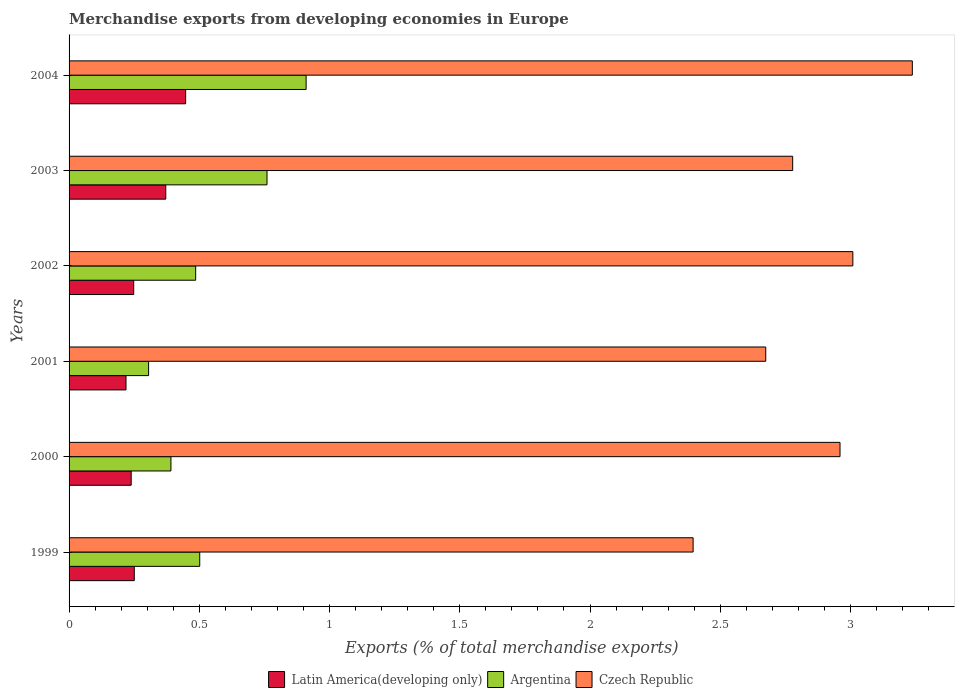Are the number of bars per tick equal to the number of legend labels?
Your answer should be compact. Yes. Are the number of bars on each tick of the Y-axis equal?
Provide a short and direct response. Yes. How many bars are there on the 2nd tick from the top?
Offer a terse response. 3. How many bars are there on the 3rd tick from the bottom?
Offer a very short reply. 3. What is the percentage of total merchandise exports in Latin America(developing only) in 2004?
Your response must be concise. 0.45. Across all years, what is the maximum percentage of total merchandise exports in Czech Republic?
Your response must be concise. 3.24. Across all years, what is the minimum percentage of total merchandise exports in Czech Republic?
Give a very brief answer. 2.4. In which year was the percentage of total merchandise exports in Argentina maximum?
Provide a short and direct response. 2004. What is the total percentage of total merchandise exports in Argentina in the graph?
Make the answer very short. 3.35. What is the difference between the percentage of total merchandise exports in Czech Republic in 1999 and that in 2002?
Your response must be concise. -0.61. What is the difference between the percentage of total merchandise exports in Latin America(developing only) in 2004 and the percentage of total merchandise exports in Czech Republic in 2003?
Provide a succinct answer. -2.33. What is the average percentage of total merchandise exports in Czech Republic per year?
Give a very brief answer. 2.84. In the year 2002, what is the difference between the percentage of total merchandise exports in Czech Republic and percentage of total merchandise exports in Latin America(developing only)?
Keep it short and to the point. 2.76. In how many years, is the percentage of total merchandise exports in Czech Republic greater than 1.6 %?
Your answer should be very brief. 6. What is the ratio of the percentage of total merchandise exports in Czech Republic in 1999 to that in 2002?
Ensure brevity in your answer.  0.8. Is the percentage of total merchandise exports in Latin America(developing only) in 2001 less than that in 2003?
Your answer should be very brief. Yes. Is the difference between the percentage of total merchandise exports in Czech Republic in 2003 and 2004 greater than the difference between the percentage of total merchandise exports in Latin America(developing only) in 2003 and 2004?
Give a very brief answer. No. What is the difference between the highest and the second highest percentage of total merchandise exports in Czech Republic?
Provide a succinct answer. 0.23. What is the difference between the highest and the lowest percentage of total merchandise exports in Argentina?
Provide a short and direct response. 0.6. In how many years, is the percentage of total merchandise exports in Czech Republic greater than the average percentage of total merchandise exports in Czech Republic taken over all years?
Your answer should be compact. 3. Is the sum of the percentage of total merchandise exports in Argentina in 2000 and 2003 greater than the maximum percentage of total merchandise exports in Latin America(developing only) across all years?
Ensure brevity in your answer.  Yes. What does the 1st bar from the top in 2001 represents?
Your answer should be compact. Czech Republic. What does the 1st bar from the bottom in 2004 represents?
Your response must be concise. Latin America(developing only). Are all the bars in the graph horizontal?
Provide a short and direct response. Yes. What is the difference between two consecutive major ticks on the X-axis?
Offer a very short reply. 0.5. Are the values on the major ticks of X-axis written in scientific E-notation?
Offer a very short reply. No. Does the graph contain grids?
Provide a short and direct response. No. How many legend labels are there?
Offer a terse response. 3. What is the title of the graph?
Your response must be concise. Merchandise exports from developing economies in Europe. Does "United Arab Emirates" appear as one of the legend labels in the graph?
Make the answer very short. No. What is the label or title of the X-axis?
Ensure brevity in your answer.  Exports (% of total merchandise exports). What is the label or title of the Y-axis?
Make the answer very short. Years. What is the Exports (% of total merchandise exports) in Latin America(developing only) in 1999?
Offer a terse response. 0.25. What is the Exports (% of total merchandise exports) in Argentina in 1999?
Your answer should be very brief. 0.5. What is the Exports (% of total merchandise exports) in Czech Republic in 1999?
Provide a succinct answer. 2.4. What is the Exports (% of total merchandise exports) in Latin America(developing only) in 2000?
Provide a succinct answer. 0.24. What is the Exports (% of total merchandise exports) in Argentina in 2000?
Ensure brevity in your answer.  0.39. What is the Exports (% of total merchandise exports) of Czech Republic in 2000?
Offer a very short reply. 2.96. What is the Exports (% of total merchandise exports) of Latin America(developing only) in 2001?
Keep it short and to the point. 0.22. What is the Exports (% of total merchandise exports) in Argentina in 2001?
Provide a succinct answer. 0.31. What is the Exports (% of total merchandise exports) of Czech Republic in 2001?
Provide a succinct answer. 2.67. What is the Exports (% of total merchandise exports) in Latin America(developing only) in 2002?
Your answer should be compact. 0.25. What is the Exports (% of total merchandise exports) of Argentina in 2002?
Make the answer very short. 0.49. What is the Exports (% of total merchandise exports) in Czech Republic in 2002?
Your answer should be compact. 3.01. What is the Exports (% of total merchandise exports) in Latin America(developing only) in 2003?
Ensure brevity in your answer.  0.37. What is the Exports (% of total merchandise exports) of Argentina in 2003?
Your answer should be very brief. 0.76. What is the Exports (% of total merchandise exports) of Czech Republic in 2003?
Offer a terse response. 2.78. What is the Exports (% of total merchandise exports) of Latin America(developing only) in 2004?
Offer a very short reply. 0.45. What is the Exports (% of total merchandise exports) of Argentina in 2004?
Your response must be concise. 0.91. What is the Exports (% of total merchandise exports) in Czech Republic in 2004?
Keep it short and to the point. 3.24. Across all years, what is the maximum Exports (% of total merchandise exports) of Latin America(developing only)?
Make the answer very short. 0.45. Across all years, what is the maximum Exports (% of total merchandise exports) of Argentina?
Give a very brief answer. 0.91. Across all years, what is the maximum Exports (% of total merchandise exports) of Czech Republic?
Your answer should be compact. 3.24. Across all years, what is the minimum Exports (% of total merchandise exports) of Latin America(developing only)?
Offer a very short reply. 0.22. Across all years, what is the minimum Exports (% of total merchandise exports) of Argentina?
Your answer should be compact. 0.31. Across all years, what is the minimum Exports (% of total merchandise exports) in Czech Republic?
Offer a very short reply. 2.4. What is the total Exports (% of total merchandise exports) of Latin America(developing only) in the graph?
Offer a very short reply. 1.77. What is the total Exports (% of total merchandise exports) of Argentina in the graph?
Ensure brevity in your answer.  3.35. What is the total Exports (% of total merchandise exports) of Czech Republic in the graph?
Provide a succinct answer. 17.05. What is the difference between the Exports (% of total merchandise exports) of Latin America(developing only) in 1999 and that in 2000?
Offer a terse response. 0.01. What is the difference between the Exports (% of total merchandise exports) in Argentina in 1999 and that in 2000?
Your response must be concise. 0.11. What is the difference between the Exports (% of total merchandise exports) of Czech Republic in 1999 and that in 2000?
Give a very brief answer. -0.56. What is the difference between the Exports (% of total merchandise exports) in Latin America(developing only) in 1999 and that in 2001?
Give a very brief answer. 0.03. What is the difference between the Exports (% of total merchandise exports) in Argentina in 1999 and that in 2001?
Keep it short and to the point. 0.2. What is the difference between the Exports (% of total merchandise exports) in Czech Republic in 1999 and that in 2001?
Offer a terse response. -0.28. What is the difference between the Exports (% of total merchandise exports) in Latin America(developing only) in 1999 and that in 2002?
Offer a very short reply. 0. What is the difference between the Exports (% of total merchandise exports) in Argentina in 1999 and that in 2002?
Offer a terse response. 0.02. What is the difference between the Exports (% of total merchandise exports) in Czech Republic in 1999 and that in 2002?
Give a very brief answer. -0.61. What is the difference between the Exports (% of total merchandise exports) of Latin America(developing only) in 1999 and that in 2003?
Provide a short and direct response. -0.12. What is the difference between the Exports (% of total merchandise exports) of Argentina in 1999 and that in 2003?
Provide a short and direct response. -0.26. What is the difference between the Exports (% of total merchandise exports) in Czech Republic in 1999 and that in 2003?
Give a very brief answer. -0.38. What is the difference between the Exports (% of total merchandise exports) of Latin America(developing only) in 1999 and that in 2004?
Ensure brevity in your answer.  -0.2. What is the difference between the Exports (% of total merchandise exports) of Argentina in 1999 and that in 2004?
Give a very brief answer. -0.41. What is the difference between the Exports (% of total merchandise exports) of Czech Republic in 1999 and that in 2004?
Keep it short and to the point. -0.84. What is the difference between the Exports (% of total merchandise exports) of Latin America(developing only) in 2000 and that in 2001?
Your answer should be very brief. 0.02. What is the difference between the Exports (% of total merchandise exports) of Argentina in 2000 and that in 2001?
Provide a succinct answer. 0.09. What is the difference between the Exports (% of total merchandise exports) of Czech Republic in 2000 and that in 2001?
Your answer should be compact. 0.29. What is the difference between the Exports (% of total merchandise exports) of Latin America(developing only) in 2000 and that in 2002?
Provide a succinct answer. -0.01. What is the difference between the Exports (% of total merchandise exports) of Argentina in 2000 and that in 2002?
Keep it short and to the point. -0.09. What is the difference between the Exports (% of total merchandise exports) of Czech Republic in 2000 and that in 2002?
Your response must be concise. -0.05. What is the difference between the Exports (% of total merchandise exports) in Latin America(developing only) in 2000 and that in 2003?
Offer a very short reply. -0.13. What is the difference between the Exports (% of total merchandise exports) in Argentina in 2000 and that in 2003?
Your answer should be compact. -0.37. What is the difference between the Exports (% of total merchandise exports) of Czech Republic in 2000 and that in 2003?
Your answer should be very brief. 0.18. What is the difference between the Exports (% of total merchandise exports) in Latin America(developing only) in 2000 and that in 2004?
Ensure brevity in your answer.  -0.21. What is the difference between the Exports (% of total merchandise exports) of Argentina in 2000 and that in 2004?
Keep it short and to the point. -0.52. What is the difference between the Exports (% of total merchandise exports) of Czech Republic in 2000 and that in 2004?
Your answer should be compact. -0.28. What is the difference between the Exports (% of total merchandise exports) in Latin America(developing only) in 2001 and that in 2002?
Provide a succinct answer. -0.03. What is the difference between the Exports (% of total merchandise exports) of Argentina in 2001 and that in 2002?
Ensure brevity in your answer.  -0.18. What is the difference between the Exports (% of total merchandise exports) in Czech Republic in 2001 and that in 2002?
Ensure brevity in your answer.  -0.33. What is the difference between the Exports (% of total merchandise exports) in Latin America(developing only) in 2001 and that in 2003?
Provide a short and direct response. -0.15. What is the difference between the Exports (% of total merchandise exports) in Argentina in 2001 and that in 2003?
Give a very brief answer. -0.45. What is the difference between the Exports (% of total merchandise exports) of Czech Republic in 2001 and that in 2003?
Your response must be concise. -0.1. What is the difference between the Exports (% of total merchandise exports) in Latin America(developing only) in 2001 and that in 2004?
Ensure brevity in your answer.  -0.23. What is the difference between the Exports (% of total merchandise exports) in Argentina in 2001 and that in 2004?
Your response must be concise. -0.6. What is the difference between the Exports (% of total merchandise exports) in Czech Republic in 2001 and that in 2004?
Provide a short and direct response. -0.56. What is the difference between the Exports (% of total merchandise exports) of Latin America(developing only) in 2002 and that in 2003?
Provide a short and direct response. -0.12. What is the difference between the Exports (% of total merchandise exports) in Argentina in 2002 and that in 2003?
Provide a short and direct response. -0.27. What is the difference between the Exports (% of total merchandise exports) of Czech Republic in 2002 and that in 2003?
Your answer should be very brief. 0.23. What is the difference between the Exports (% of total merchandise exports) in Latin America(developing only) in 2002 and that in 2004?
Your answer should be very brief. -0.2. What is the difference between the Exports (% of total merchandise exports) in Argentina in 2002 and that in 2004?
Provide a short and direct response. -0.42. What is the difference between the Exports (% of total merchandise exports) in Czech Republic in 2002 and that in 2004?
Offer a terse response. -0.23. What is the difference between the Exports (% of total merchandise exports) of Latin America(developing only) in 2003 and that in 2004?
Your answer should be very brief. -0.08. What is the difference between the Exports (% of total merchandise exports) in Argentina in 2003 and that in 2004?
Provide a short and direct response. -0.15. What is the difference between the Exports (% of total merchandise exports) of Czech Republic in 2003 and that in 2004?
Give a very brief answer. -0.46. What is the difference between the Exports (% of total merchandise exports) in Latin America(developing only) in 1999 and the Exports (% of total merchandise exports) in Argentina in 2000?
Make the answer very short. -0.14. What is the difference between the Exports (% of total merchandise exports) of Latin America(developing only) in 1999 and the Exports (% of total merchandise exports) of Czech Republic in 2000?
Provide a succinct answer. -2.71. What is the difference between the Exports (% of total merchandise exports) in Argentina in 1999 and the Exports (% of total merchandise exports) in Czech Republic in 2000?
Keep it short and to the point. -2.46. What is the difference between the Exports (% of total merchandise exports) in Latin America(developing only) in 1999 and the Exports (% of total merchandise exports) in Argentina in 2001?
Ensure brevity in your answer.  -0.06. What is the difference between the Exports (% of total merchandise exports) in Latin America(developing only) in 1999 and the Exports (% of total merchandise exports) in Czech Republic in 2001?
Give a very brief answer. -2.42. What is the difference between the Exports (% of total merchandise exports) in Argentina in 1999 and the Exports (% of total merchandise exports) in Czech Republic in 2001?
Give a very brief answer. -2.17. What is the difference between the Exports (% of total merchandise exports) in Latin America(developing only) in 1999 and the Exports (% of total merchandise exports) in Argentina in 2002?
Provide a short and direct response. -0.24. What is the difference between the Exports (% of total merchandise exports) in Latin America(developing only) in 1999 and the Exports (% of total merchandise exports) in Czech Republic in 2002?
Your answer should be compact. -2.76. What is the difference between the Exports (% of total merchandise exports) in Argentina in 1999 and the Exports (% of total merchandise exports) in Czech Republic in 2002?
Provide a succinct answer. -2.51. What is the difference between the Exports (% of total merchandise exports) of Latin America(developing only) in 1999 and the Exports (% of total merchandise exports) of Argentina in 2003?
Keep it short and to the point. -0.51. What is the difference between the Exports (% of total merchandise exports) of Latin America(developing only) in 1999 and the Exports (% of total merchandise exports) of Czech Republic in 2003?
Ensure brevity in your answer.  -2.53. What is the difference between the Exports (% of total merchandise exports) of Argentina in 1999 and the Exports (% of total merchandise exports) of Czech Republic in 2003?
Your answer should be compact. -2.28. What is the difference between the Exports (% of total merchandise exports) of Latin America(developing only) in 1999 and the Exports (% of total merchandise exports) of Argentina in 2004?
Your answer should be very brief. -0.66. What is the difference between the Exports (% of total merchandise exports) of Latin America(developing only) in 1999 and the Exports (% of total merchandise exports) of Czech Republic in 2004?
Keep it short and to the point. -2.99. What is the difference between the Exports (% of total merchandise exports) in Argentina in 1999 and the Exports (% of total merchandise exports) in Czech Republic in 2004?
Your answer should be compact. -2.74. What is the difference between the Exports (% of total merchandise exports) in Latin America(developing only) in 2000 and the Exports (% of total merchandise exports) in Argentina in 2001?
Provide a succinct answer. -0.07. What is the difference between the Exports (% of total merchandise exports) of Latin America(developing only) in 2000 and the Exports (% of total merchandise exports) of Czech Republic in 2001?
Your answer should be compact. -2.44. What is the difference between the Exports (% of total merchandise exports) in Argentina in 2000 and the Exports (% of total merchandise exports) in Czech Republic in 2001?
Make the answer very short. -2.28. What is the difference between the Exports (% of total merchandise exports) of Latin America(developing only) in 2000 and the Exports (% of total merchandise exports) of Argentina in 2002?
Provide a succinct answer. -0.25. What is the difference between the Exports (% of total merchandise exports) in Latin America(developing only) in 2000 and the Exports (% of total merchandise exports) in Czech Republic in 2002?
Offer a very short reply. -2.77. What is the difference between the Exports (% of total merchandise exports) of Argentina in 2000 and the Exports (% of total merchandise exports) of Czech Republic in 2002?
Your answer should be compact. -2.62. What is the difference between the Exports (% of total merchandise exports) of Latin America(developing only) in 2000 and the Exports (% of total merchandise exports) of Argentina in 2003?
Provide a succinct answer. -0.52. What is the difference between the Exports (% of total merchandise exports) in Latin America(developing only) in 2000 and the Exports (% of total merchandise exports) in Czech Republic in 2003?
Make the answer very short. -2.54. What is the difference between the Exports (% of total merchandise exports) in Argentina in 2000 and the Exports (% of total merchandise exports) in Czech Republic in 2003?
Provide a short and direct response. -2.39. What is the difference between the Exports (% of total merchandise exports) in Latin America(developing only) in 2000 and the Exports (% of total merchandise exports) in Argentina in 2004?
Your answer should be very brief. -0.67. What is the difference between the Exports (% of total merchandise exports) in Latin America(developing only) in 2000 and the Exports (% of total merchandise exports) in Czech Republic in 2004?
Your answer should be very brief. -3. What is the difference between the Exports (% of total merchandise exports) of Argentina in 2000 and the Exports (% of total merchandise exports) of Czech Republic in 2004?
Your response must be concise. -2.85. What is the difference between the Exports (% of total merchandise exports) of Latin America(developing only) in 2001 and the Exports (% of total merchandise exports) of Argentina in 2002?
Offer a terse response. -0.27. What is the difference between the Exports (% of total merchandise exports) of Latin America(developing only) in 2001 and the Exports (% of total merchandise exports) of Czech Republic in 2002?
Offer a very short reply. -2.79. What is the difference between the Exports (% of total merchandise exports) in Argentina in 2001 and the Exports (% of total merchandise exports) in Czech Republic in 2002?
Your answer should be compact. -2.7. What is the difference between the Exports (% of total merchandise exports) in Latin America(developing only) in 2001 and the Exports (% of total merchandise exports) in Argentina in 2003?
Offer a terse response. -0.54. What is the difference between the Exports (% of total merchandise exports) in Latin America(developing only) in 2001 and the Exports (% of total merchandise exports) in Czech Republic in 2003?
Offer a very short reply. -2.56. What is the difference between the Exports (% of total merchandise exports) of Argentina in 2001 and the Exports (% of total merchandise exports) of Czech Republic in 2003?
Provide a short and direct response. -2.47. What is the difference between the Exports (% of total merchandise exports) of Latin America(developing only) in 2001 and the Exports (% of total merchandise exports) of Argentina in 2004?
Provide a succinct answer. -0.69. What is the difference between the Exports (% of total merchandise exports) of Latin America(developing only) in 2001 and the Exports (% of total merchandise exports) of Czech Republic in 2004?
Your response must be concise. -3.02. What is the difference between the Exports (% of total merchandise exports) of Argentina in 2001 and the Exports (% of total merchandise exports) of Czech Republic in 2004?
Keep it short and to the point. -2.93. What is the difference between the Exports (% of total merchandise exports) in Latin America(developing only) in 2002 and the Exports (% of total merchandise exports) in Argentina in 2003?
Your response must be concise. -0.51. What is the difference between the Exports (% of total merchandise exports) of Latin America(developing only) in 2002 and the Exports (% of total merchandise exports) of Czech Republic in 2003?
Your answer should be very brief. -2.53. What is the difference between the Exports (% of total merchandise exports) in Argentina in 2002 and the Exports (% of total merchandise exports) in Czech Republic in 2003?
Provide a succinct answer. -2.29. What is the difference between the Exports (% of total merchandise exports) in Latin America(developing only) in 2002 and the Exports (% of total merchandise exports) in Argentina in 2004?
Provide a succinct answer. -0.66. What is the difference between the Exports (% of total merchandise exports) in Latin America(developing only) in 2002 and the Exports (% of total merchandise exports) in Czech Republic in 2004?
Your answer should be very brief. -2.99. What is the difference between the Exports (% of total merchandise exports) in Argentina in 2002 and the Exports (% of total merchandise exports) in Czech Republic in 2004?
Keep it short and to the point. -2.75. What is the difference between the Exports (% of total merchandise exports) of Latin America(developing only) in 2003 and the Exports (% of total merchandise exports) of Argentina in 2004?
Offer a terse response. -0.54. What is the difference between the Exports (% of total merchandise exports) of Latin America(developing only) in 2003 and the Exports (% of total merchandise exports) of Czech Republic in 2004?
Offer a terse response. -2.87. What is the difference between the Exports (% of total merchandise exports) in Argentina in 2003 and the Exports (% of total merchandise exports) in Czech Republic in 2004?
Your answer should be very brief. -2.48. What is the average Exports (% of total merchandise exports) in Latin America(developing only) per year?
Your response must be concise. 0.3. What is the average Exports (% of total merchandise exports) of Argentina per year?
Offer a terse response. 0.56. What is the average Exports (% of total merchandise exports) in Czech Republic per year?
Offer a very short reply. 2.84. In the year 1999, what is the difference between the Exports (% of total merchandise exports) in Latin America(developing only) and Exports (% of total merchandise exports) in Argentina?
Provide a short and direct response. -0.25. In the year 1999, what is the difference between the Exports (% of total merchandise exports) of Latin America(developing only) and Exports (% of total merchandise exports) of Czech Republic?
Your answer should be very brief. -2.15. In the year 1999, what is the difference between the Exports (% of total merchandise exports) in Argentina and Exports (% of total merchandise exports) in Czech Republic?
Offer a very short reply. -1.89. In the year 2000, what is the difference between the Exports (% of total merchandise exports) of Latin America(developing only) and Exports (% of total merchandise exports) of Argentina?
Offer a terse response. -0.15. In the year 2000, what is the difference between the Exports (% of total merchandise exports) in Latin America(developing only) and Exports (% of total merchandise exports) in Czech Republic?
Provide a short and direct response. -2.72. In the year 2000, what is the difference between the Exports (% of total merchandise exports) of Argentina and Exports (% of total merchandise exports) of Czech Republic?
Provide a succinct answer. -2.57. In the year 2001, what is the difference between the Exports (% of total merchandise exports) of Latin America(developing only) and Exports (% of total merchandise exports) of Argentina?
Ensure brevity in your answer.  -0.09. In the year 2001, what is the difference between the Exports (% of total merchandise exports) in Latin America(developing only) and Exports (% of total merchandise exports) in Czech Republic?
Your answer should be very brief. -2.46. In the year 2001, what is the difference between the Exports (% of total merchandise exports) of Argentina and Exports (% of total merchandise exports) of Czech Republic?
Provide a succinct answer. -2.37. In the year 2002, what is the difference between the Exports (% of total merchandise exports) of Latin America(developing only) and Exports (% of total merchandise exports) of Argentina?
Offer a terse response. -0.24. In the year 2002, what is the difference between the Exports (% of total merchandise exports) of Latin America(developing only) and Exports (% of total merchandise exports) of Czech Republic?
Your answer should be compact. -2.76. In the year 2002, what is the difference between the Exports (% of total merchandise exports) in Argentina and Exports (% of total merchandise exports) in Czech Republic?
Ensure brevity in your answer.  -2.52. In the year 2003, what is the difference between the Exports (% of total merchandise exports) in Latin America(developing only) and Exports (% of total merchandise exports) in Argentina?
Your answer should be very brief. -0.39. In the year 2003, what is the difference between the Exports (% of total merchandise exports) in Latin America(developing only) and Exports (% of total merchandise exports) in Czech Republic?
Your answer should be very brief. -2.41. In the year 2003, what is the difference between the Exports (% of total merchandise exports) in Argentina and Exports (% of total merchandise exports) in Czech Republic?
Give a very brief answer. -2.02. In the year 2004, what is the difference between the Exports (% of total merchandise exports) in Latin America(developing only) and Exports (% of total merchandise exports) in Argentina?
Your answer should be compact. -0.46. In the year 2004, what is the difference between the Exports (% of total merchandise exports) of Latin America(developing only) and Exports (% of total merchandise exports) of Czech Republic?
Ensure brevity in your answer.  -2.79. In the year 2004, what is the difference between the Exports (% of total merchandise exports) of Argentina and Exports (% of total merchandise exports) of Czech Republic?
Offer a terse response. -2.33. What is the ratio of the Exports (% of total merchandise exports) of Latin America(developing only) in 1999 to that in 2000?
Your answer should be very brief. 1.05. What is the ratio of the Exports (% of total merchandise exports) of Argentina in 1999 to that in 2000?
Ensure brevity in your answer.  1.28. What is the ratio of the Exports (% of total merchandise exports) of Czech Republic in 1999 to that in 2000?
Give a very brief answer. 0.81. What is the ratio of the Exports (% of total merchandise exports) of Latin America(developing only) in 1999 to that in 2001?
Your response must be concise. 1.15. What is the ratio of the Exports (% of total merchandise exports) of Argentina in 1999 to that in 2001?
Offer a very short reply. 1.64. What is the ratio of the Exports (% of total merchandise exports) of Czech Republic in 1999 to that in 2001?
Ensure brevity in your answer.  0.9. What is the ratio of the Exports (% of total merchandise exports) in Argentina in 1999 to that in 2002?
Your answer should be compact. 1.03. What is the ratio of the Exports (% of total merchandise exports) in Czech Republic in 1999 to that in 2002?
Your answer should be compact. 0.8. What is the ratio of the Exports (% of total merchandise exports) in Latin America(developing only) in 1999 to that in 2003?
Give a very brief answer. 0.67. What is the ratio of the Exports (% of total merchandise exports) of Argentina in 1999 to that in 2003?
Make the answer very short. 0.66. What is the ratio of the Exports (% of total merchandise exports) of Czech Republic in 1999 to that in 2003?
Ensure brevity in your answer.  0.86. What is the ratio of the Exports (% of total merchandise exports) of Latin America(developing only) in 1999 to that in 2004?
Provide a succinct answer. 0.56. What is the ratio of the Exports (% of total merchandise exports) of Argentina in 1999 to that in 2004?
Keep it short and to the point. 0.55. What is the ratio of the Exports (% of total merchandise exports) of Czech Republic in 1999 to that in 2004?
Your response must be concise. 0.74. What is the ratio of the Exports (% of total merchandise exports) of Latin America(developing only) in 2000 to that in 2001?
Provide a succinct answer. 1.09. What is the ratio of the Exports (% of total merchandise exports) of Argentina in 2000 to that in 2001?
Make the answer very short. 1.28. What is the ratio of the Exports (% of total merchandise exports) of Czech Republic in 2000 to that in 2001?
Offer a terse response. 1.11. What is the ratio of the Exports (% of total merchandise exports) of Latin America(developing only) in 2000 to that in 2002?
Offer a very short reply. 0.96. What is the ratio of the Exports (% of total merchandise exports) in Argentina in 2000 to that in 2002?
Offer a terse response. 0.8. What is the ratio of the Exports (% of total merchandise exports) of Czech Republic in 2000 to that in 2002?
Provide a succinct answer. 0.98. What is the ratio of the Exports (% of total merchandise exports) of Latin America(developing only) in 2000 to that in 2003?
Give a very brief answer. 0.64. What is the ratio of the Exports (% of total merchandise exports) in Argentina in 2000 to that in 2003?
Give a very brief answer. 0.51. What is the ratio of the Exports (% of total merchandise exports) of Czech Republic in 2000 to that in 2003?
Offer a very short reply. 1.07. What is the ratio of the Exports (% of total merchandise exports) in Latin America(developing only) in 2000 to that in 2004?
Give a very brief answer. 0.53. What is the ratio of the Exports (% of total merchandise exports) in Argentina in 2000 to that in 2004?
Give a very brief answer. 0.43. What is the ratio of the Exports (% of total merchandise exports) in Czech Republic in 2000 to that in 2004?
Your response must be concise. 0.91. What is the ratio of the Exports (% of total merchandise exports) in Latin America(developing only) in 2001 to that in 2002?
Offer a terse response. 0.88. What is the ratio of the Exports (% of total merchandise exports) of Argentina in 2001 to that in 2002?
Offer a terse response. 0.63. What is the ratio of the Exports (% of total merchandise exports) in Latin America(developing only) in 2001 to that in 2003?
Offer a terse response. 0.59. What is the ratio of the Exports (% of total merchandise exports) of Argentina in 2001 to that in 2003?
Provide a succinct answer. 0.4. What is the ratio of the Exports (% of total merchandise exports) in Czech Republic in 2001 to that in 2003?
Your response must be concise. 0.96. What is the ratio of the Exports (% of total merchandise exports) of Latin America(developing only) in 2001 to that in 2004?
Provide a succinct answer. 0.49. What is the ratio of the Exports (% of total merchandise exports) in Argentina in 2001 to that in 2004?
Provide a succinct answer. 0.34. What is the ratio of the Exports (% of total merchandise exports) of Czech Republic in 2001 to that in 2004?
Offer a very short reply. 0.83. What is the ratio of the Exports (% of total merchandise exports) in Latin America(developing only) in 2002 to that in 2003?
Your answer should be compact. 0.67. What is the ratio of the Exports (% of total merchandise exports) of Argentina in 2002 to that in 2003?
Give a very brief answer. 0.64. What is the ratio of the Exports (% of total merchandise exports) of Czech Republic in 2002 to that in 2003?
Provide a short and direct response. 1.08. What is the ratio of the Exports (% of total merchandise exports) in Latin America(developing only) in 2002 to that in 2004?
Offer a terse response. 0.55. What is the ratio of the Exports (% of total merchandise exports) of Argentina in 2002 to that in 2004?
Give a very brief answer. 0.53. What is the ratio of the Exports (% of total merchandise exports) in Czech Republic in 2002 to that in 2004?
Your answer should be compact. 0.93. What is the ratio of the Exports (% of total merchandise exports) in Latin America(developing only) in 2003 to that in 2004?
Keep it short and to the point. 0.83. What is the ratio of the Exports (% of total merchandise exports) in Argentina in 2003 to that in 2004?
Your response must be concise. 0.83. What is the ratio of the Exports (% of total merchandise exports) of Czech Republic in 2003 to that in 2004?
Your answer should be very brief. 0.86. What is the difference between the highest and the second highest Exports (% of total merchandise exports) in Latin America(developing only)?
Make the answer very short. 0.08. What is the difference between the highest and the second highest Exports (% of total merchandise exports) in Argentina?
Your answer should be very brief. 0.15. What is the difference between the highest and the second highest Exports (% of total merchandise exports) of Czech Republic?
Offer a very short reply. 0.23. What is the difference between the highest and the lowest Exports (% of total merchandise exports) in Latin America(developing only)?
Your response must be concise. 0.23. What is the difference between the highest and the lowest Exports (% of total merchandise exports) of Argentina?
Provide a succinct answer. 0.6. What is the difference between the highest and the lowest Exports (% of total merchandise exports) of Czech Republic?
Ensure brevity in your answer.  0.84. 